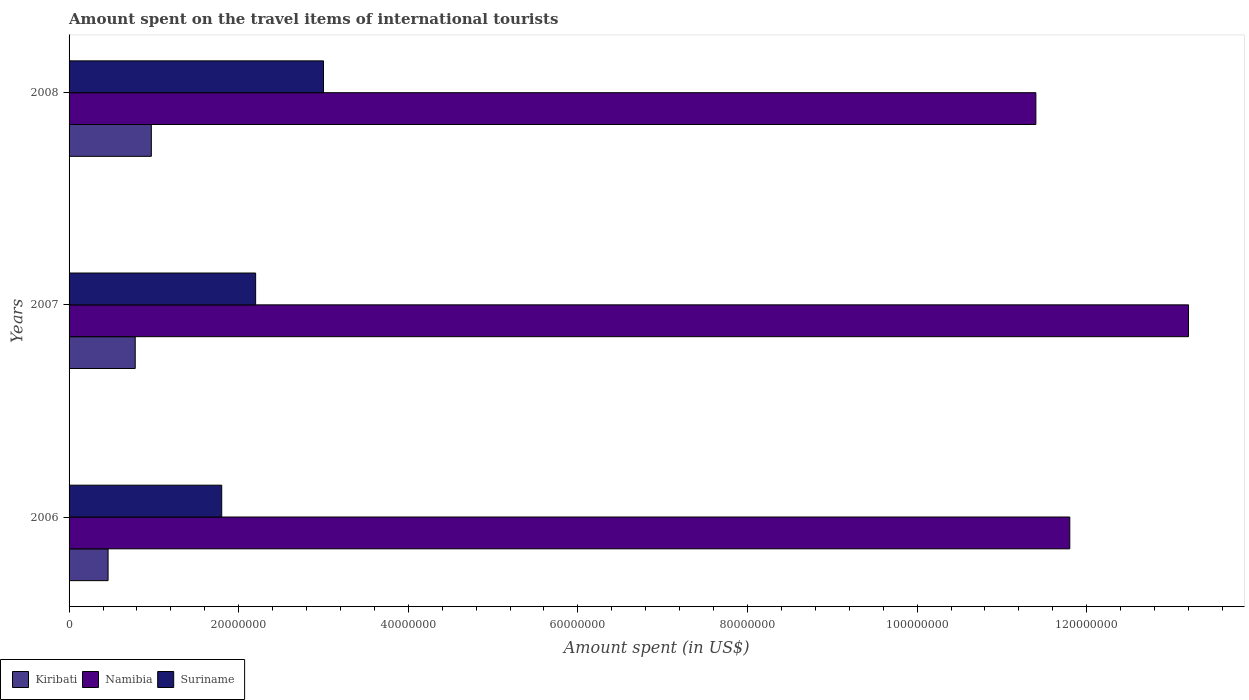How many different coloured bars are there?
Make the answer very short. 3. Are the number of bars per tick equal to the number of legend labels?
Provide a short and direct response. Yes. How many bars are there on the 1st tick from the bottom?
Offer a very short reply. 3. What is the label of the 1st group of bars from the top?
Make the answer very short. 2008. What is the amount spent on the travel items of international tourists in Kiribati in 2006?
Your response must be concise. 4.60e+06. Across all years, what is the maximum amount spent on the travel items of international tourists in Kiribati?
Make the answer very short. 9.70e+06. Across all years, what is the minimum amount spent on the travel items of international tourists in Namibia?
Your answer should be very brief. 1.14e+08. In which year was the amount spent on the travel items of international tourists in Kiribati maximum?
Your response must be concise. 2008. In which year was the amount spent on the travel items of international tourists in Kiribati minimum?
Ensure brevity in your answer.  2006. What is the total amount spent on the travel items of international tourists in Namibia in the graph?
Your response must be concise. 3.64e+08. What is the difference between the amount spent on the travel items of international tourists in Namibia in 2007 and that in 2008?
Your answer should be compact. 1.80e+07. What is the difference between the amount spent on the travel items of international tourists in Namibia in 2006 and the amount spent on the travel items of international tourists in Suriname in 2007?
Provide a short and direct response. 9.60e+07. What is the average amount spent on the travel items of international tourists in Kiribati per year?
Your answer should be compact. 7.37e+06. In the year 2007, what is the difference between the amount spent on the travel items of international tourists in Kiribati and amount spent on the travel items of international tourists in Suriname?
Offer a terse response. -1.42e+07. What is the ratio of the amount spent on the travel items of international tourists in Kiribati in 2006 to that in 2007?
Keep it short and to the point. 0.59. Is the amount spent on the travel items of international tourists in Suriname in 2006 less than that in 2008?
Provide a succinct answer. Yes. Is the difference between the amount spent on the travel items of international tourists in Kiribati in 2007 and 2008 greater than the difference between the amount spent on the travel items of international tourists in Suriname in 2007 and 2008?
Your answer should be compact. Yes. What is the difference between the highest and the second highest amount spent on the travel items of international tourists in Namibia?
Your answer should be compact. 1.40e+07. What is the difference between the highest and the lowest amount spent on the travel items of international tourists in Suriname?
Offer a terse response. 1.20e+07. In how many years, is the amount spent on the travel items of international tourists in Suriname greater than the average amount spent on the travel items of international tourists in Suriname taken over all years?
Provide a short and direct response. 1. Is the sum of the amount spent on the travel items of international tourists in Suriname in 2006 and 2008 greater than the maximum amount spent on the travel items of international tourists in Namibia across all years?
Provide a short and direct response. No. What does the 1st bar from the top in 2007 represents?
Make the answer very short. Suriname. What does the 2nd bar from the bottom in 2006 represents?
Offer a very short reply. Namibia. How many bars are there?
Offer a terse response. 9. Are all the bars in the graph horizontal?
Offer a very short reply. Yes. How many years are there in the graph?
Your response must be concise. 3. What is the difference between two consecutive major ticks on the X-axis?
Make the answer very short. 2.00e+07. Does the graph contain grids?
Ensure brevity in your answer.  No. Where does the legend appear in the graph?
Give a very brief answer. Bottom left. How many legend labels are there?
Your answer should be compact. 3. What is the title of the graph?
Make the answer very short. Amount spent on the travel items of international tourists. Does "South Sudan" appear as one of the legend labels in the graph?
Your answer should be very brief. No. What is the label or title of the X-axis?
Your response must be concise. Amount spent (in US$). What is the label or title of the Y-axis?
Your response must be concise. Years. What is the Amount spent (in US$) of Kiribati in 2006?
Offer a terse response. 4.60e+06. What is the Amount spent (in US$) in Namibia in 2006?
Keep it short and to the point. 1.18e+08. What is the Amount spent (in US$) in Suriname in 2006?
Keep it short and to the point. 1.80e+07. What is the Amount spent (in US$) of Kiribati in 2007?
Provide a succinct answer. 7.80e+06. What is the Amount spent (in US$) of Namibia in 2007?
Ensure brevity in your answer.  1.32e+08. What is the Amount spent (in US$) in Suriname in 2007?
Provide a succinct answer. 2.20e+07. What is the Amount spent (in US$) in Kiribati in 2008?
Your response must be concise. 9.70e+06. What is the Amount spent (in US$) of Namibia in 2008?
Your response must be concise. 1.14e+08. What is the Amount spent (in US$) in Suriname in 2008?
Provide a short and direct response. 3.00e+07. Across all years, what is the maximum Amount spent (in US$) of Kiribati?
Give a very brief answer. 9.70e+06. Across all years, what is the maximum Amount spent (in US$) in Namibia?
Your answer should be compact. 1.32e+08. Across all years, what is the maximum Amount spent (in US$) of Suriname?
Give a very brief answer. 3.00e+07. Across all years, what is the minimum Amount spent (in US$) in Kiribati?
Ensure brevity in your answer.  4.60e+06. Across all years, what is the minimum Amount spent (in US$) of Namibia?
Offer a very short reply. 1.14e+08. Across all years, what is the minimum Amount spent (in US$) in Suriname?
Your response must be concise. 1.80e+07. What is the total Amount spent (in US$) of Kiribati in the graph?
Offer a very short reply. 2.21e+07. What is the total Amount spent (in US$) in Namibia in the graph?
Keep it short and to the point. 3.64e+08. What is the total Amount spent (in US$) in Suriname in the graph?
Your answer should be compact. 7.00e+07. What is the difference between the Amount spent (in US$) in Kiribati in 2006 and that in 2007?
Keep it short and to the point. -3.20e+06. What is the difference between the Amount spent (in US$) of Namibia in 2006 and that in 2007?
Provide a short and direct response. -1.40e+07. What is the difference between the Amount spent (in US$) in Suriname in 2006 and that in 2007?
Your answer should be compact. -4.00e+06. What is the difference between the Amount spent (in US$) of Kiribati in 2006 and that in 2008?
Make the answer very short. -5.10e+06. What is the difference between the Amount spent (in US$) in Namibia in 2006 and that in 2008?
Give a very brief answer. 4.00e+06. What is the difference between the Amount spent (in US$) in Suriname in 2006 and that in 2008?
Ensure brevity in your answer.  -1.20e+07. What is the difference between the Amount spent (in US$) in Kiribati in 2007 and that in 2008?
Your answer should be very brief. -1.90e+06. What is the difference between the Amount spent (in US$) of Namibia in 2007 and that in 2008?
Your answer should be compact. 1.80e+07. What is the difference between the Amount spent (in US$) of Suriname in 2007 and that in 2008?
Your answer should be compact. -8.00e+06. What is the difference between the Amount spent (in US$) of Kiribati in 2006 and the Amount spent (in US$) of Namibia in 2007?
Provide a succinct answer. -1.27e+08. What is the difference between the Amount spent (in US$) in Kiribati in 2006 and the Amount spent (in US$) in Suriname in 2007?
Your response must be concise. -1.74e+07. What is the difference between the Amount spent (in US$) in Namibia in 2006 and the Amount spent (in US$) in Suriname in 2007?
Your response must be concise. 9.60e+07. What is the difference between the Amount spent (in US$) in Kiribati in 2006 and the Amount spent (in US$) in Namibia in 2008?
Give a very brief answer. -1.09e+08. What is the difference between the Amount spent (in US$) in Kiribati in 2006 and the Amount spent (in US$) in Suriname in 2008?
Ensure brevity in your answer.  -2.54e+07. What is the difference between the Amount spent (in US$) in Namibia in 2006 and the Amount spent (in US$) in Suriname in 2008?
Your answer should be compact. 8.80e+07. What is the difference between the Amount spent (in US$) of Kiribati in 2007 and the Amount spent (in US$) of Namibia in 2008?
Provide a succinct answer. -1.06e+08. What is the difference between the Amount spent (in US$) of Kiribati in 2007 and the Amount spent (in US$) of Suriname in 2008?
Give a very brief answer. -2.22e+07. What is the difference between the Amount spent (in US$) of Namibia in 2007 and the Amount spent (in US$) of Suriname in 2008?
Ensure brevity in your answer.  1.02e+08. What is the average Amount spent (in US$) in Kiribati per year?
Provide a short and direct response. 7.37e+06. What is the average Amount spent (in US$) in Namibia per year?
Keep it short and to the point. 1.21e+08. What is the average Amount spent (in US$) in Suriname per year?
Keep it short and to the point. 2.33e+07. In the year 2006, what is the difference between the Amount spent (in US$) of Kiribati and Amount spent (in US$) of Namibia?
Provide a short and direct response. -1.13e+08. In the year 2006, what is the difference between the Amount spent (in US$) in Kiribati and Amount spent (in US$) in Suriname?
Give a very brief answer. -1.34e+07. In the year 2006, what is the difference between the Amount spent (in US$) in Namibia and Amount spent (in US$) in Suriname?
Offer a very short reply. 1.00e+08. In the year 2007, what is the difference between the Amount spent (in US$) of Kiribati and Amount spent (in US$) of Namibia?
Your answer should be very brief. -1.24e+08. In the year 2007, what is the difference between the Amount spent (in US$) in Kiribati and Amount spent (in US$) in Suriname?
Ensure brevity in your answer.  -1.42e+07. In the year 2007, what is the difference between the Amount spent (in US$) in Namibia and Amount spent (in US$) in Suriname?
Ensure brevity in your answer.  1.10e+08. In the year 2008, what is the difference between the Amount spent (in US$) of Kiribati and Amount spent (in US$) of Namibia?
Your answer should be compact. -1.04e+08. In the year 2008, what is the difference between the Amount spent (in US$) of Kiribati and Amount spent (in US$) of Suriname?
Give a very brief answer. -2.03e+07. In the year 2008, what is the difference between the Amount spent (in US$) of Namibia and Amount spent (in US$) of Suriname?
Give a very brief answer. 8.40e+07. What is the ratio of the Amount spent (in US$) of Kiribati in 2006 to that in 2007?
Offer a very short reply. 0.59. What is the ratio of the Amount spent (in US$) of Namibia in 2006 to that in 2007?
Make the answer very short. 0.89. What is the ratio of the Amount spent (in US$) of Suriname in 2006 to that in 2007?
Keep it short and to the point. 0.82. What is the ratio of the Amount spent (in US$) of Kiribati in 2006 to that in 2008?
Offer a terse response. 0.47. What is the ratio of the Amount spent (in US$) of Namibia in 2006 to that in 2008?
Your answer should be very brief. 1.04. What is the ratio of the Amount spent (in US$) of Kiribati in 2007 to that in 2008?
Give a very brief answer. 0.8. What is the ratio of the Amount spent (in US$) in Namibia in 2007 to that in 2008?
Your response must be concise. 1.16. What is the ratio of the Amount spent (in US$) of Suriname in 2007 to that in 2008?
Your response must be concise. 0.73. What is the difference between the highest and the second highest Amount spent (in US$) in Kiribati?
Offer a terse response. 1.90e+06. What is the difference between the highest and the second highest Amount spent (in US$) in Namibia?
Provide a short and direct response. 1.40e+07. What is the difference between the highest and the second highest Amount spent (in US$) in Suriname?
Give a very brief answer. 8.00e+06. What is the difference between the highest and the lowest Amount spent (in US$) in Kiribati?
Offer a terse response. 5.10e+06. What is the difference between the highest and the lowest Amount spent (in US$) of Namibia?
Give a very brief answer. 1.80e+07. What is the difference between the highest and the lowest Amount spent (in US$) of Suriname?
Your answer should be compact. 1.20e+07. 